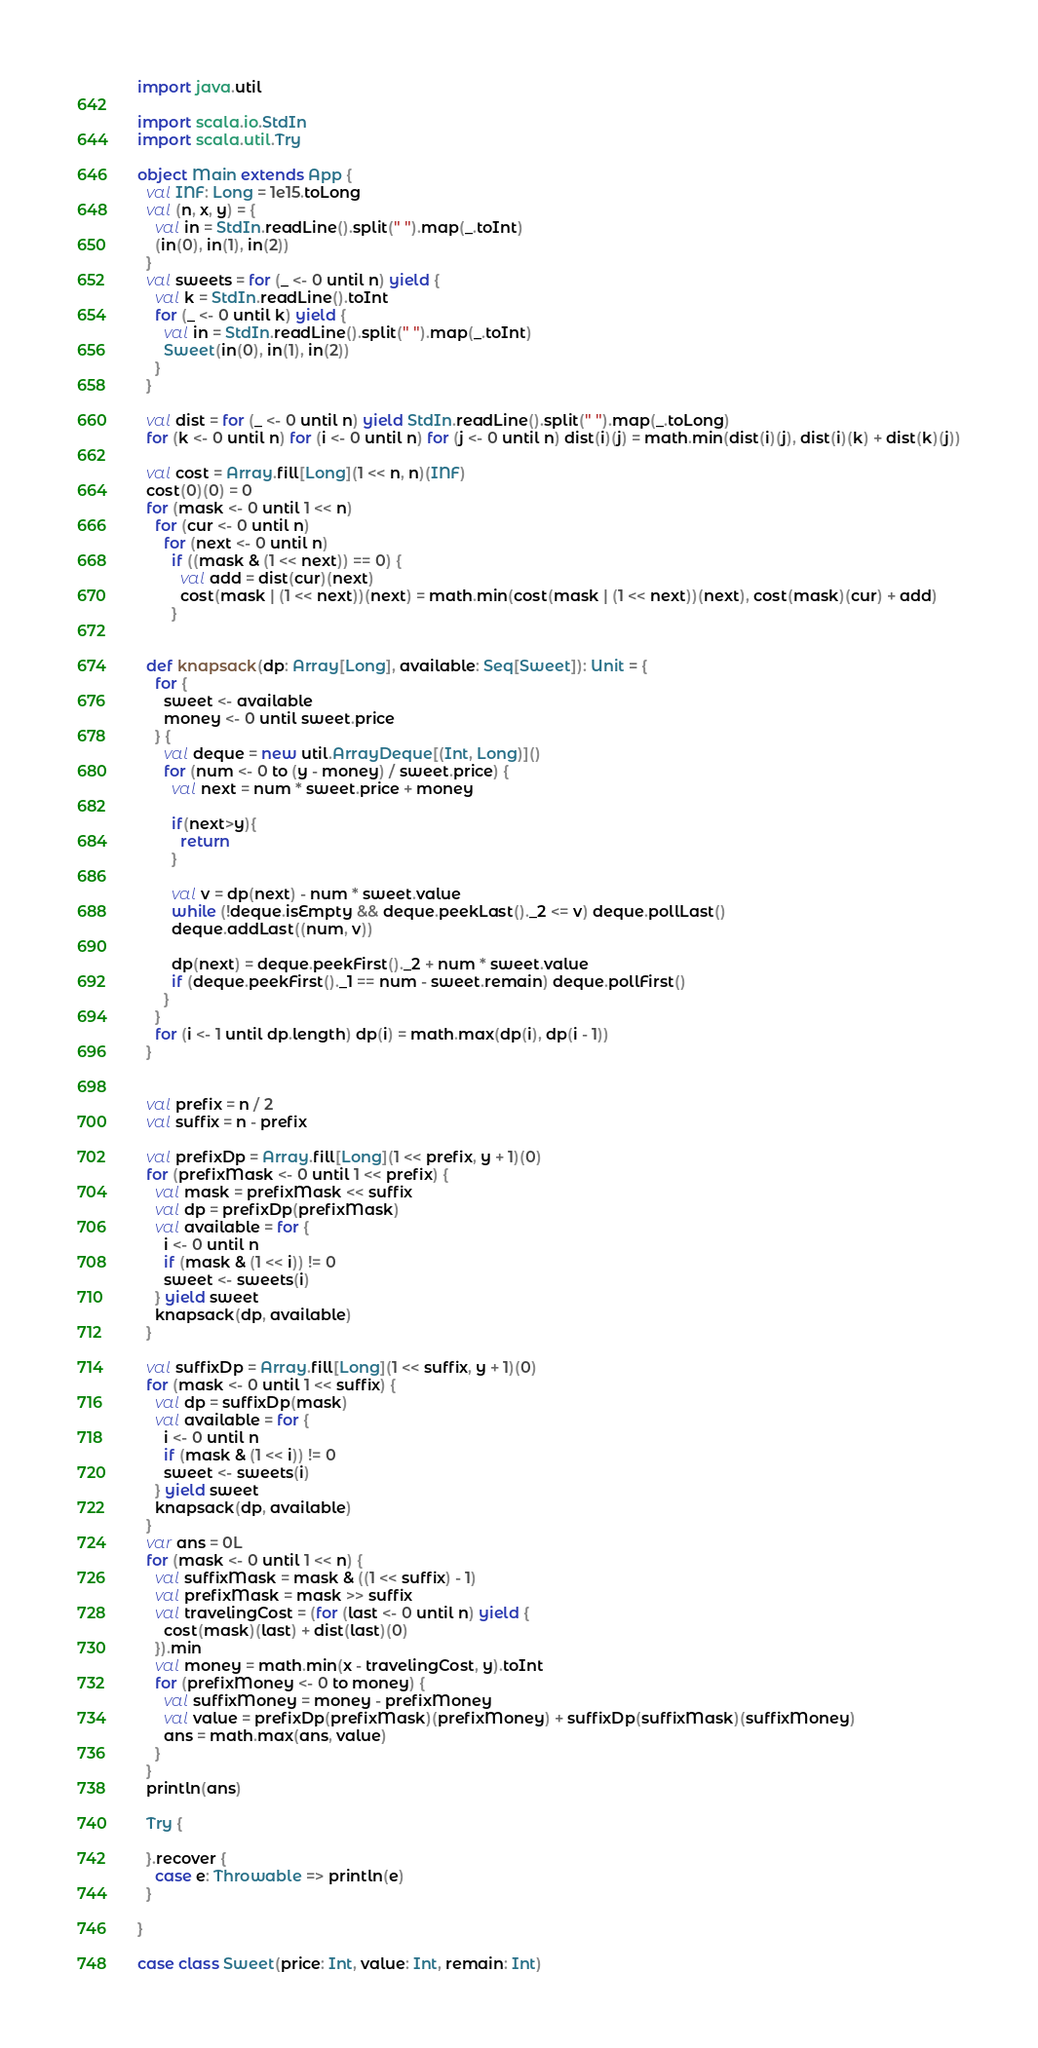Convert code to text. <code><loc_0><loc_0><loc_500><loc_500><_Scala_>import java.util

import scala.io.StdIn
import scala.util.Try

object Main extends App {
  val INF: Long = 1e15.toLong
  val (n, x, y) = {
    val in = StdIn.readLine().split(" ").map(_.toInt)
    (in(0), in(1), in(2))
  }
  val sweets = for (_ <- 0 until n) yield {
    val k = StdIn.readLine().toInt
    for (_ <- 0 until k) yield {
      val in = StdIn.readLine().split(" ").map(_.toInt)
      Sweet(in(0), in(1), in(2))
    }
  }

  val dist = for (_ <- 0 until n) yield StdIn.readLine().split(" ").map(_.toLong)
  for (k <- 0 until n) for (i <- 0 until n) for (j <- 0 until n) dist(i)(j) = math.min(dist(i)(j), dist(i)(k) + dist(k)(j))

  val cost = Array.fill[Long](1 << n, n)(INF)
  cost(0)(0) = 0
  for (mask <- 0 until 1 << n)
    for (cur <- 0 until n)
      for (next <- 0 until n)
        if ((mask & (1 << next)) == 0) {
          val add = dist(cur)(next)
          cost(mask | (1 << next))(next) = math.min(cost(mask | (1 << next))(next), cost(mask)(cur) + add)
        }


  def knapsack(dp: Array[Long], available: Seq[Sweet]): Unit = {
    for {
      sweet <- available
      money <- 0 until sweet.price
    } {
      val deque = new util.ArrayDeque[(Int, Long)]()
      for (num <- 0 to (y - money) / sweet.price) {
        val next = num * sweet.price + money

        if(next>y){
          return 
        }

        val v = dp(next) - num * sweet.value
        while (!deque.isEmpty && deque.peekLast()._2 <= v) deque.pollLast()
        deque.addLast((num, v))

        dp(next) = deque.peekFirst()._2 + num * sweet.value
        if (deque.peekFirst()._1 == num - sweet.remain) deque.pollFirst()
      }
    }
    for (i <- 1 until dp.length) dp(i) = math.max(dp(i), dp(i - 1))
  }


  val prefix = n / 2
  val suffix = n - prefix

  val prefixDp = Array.fill[Long](1 << prefix, y + 1)(0)
  for (prefixMask <- 0 until 1 << prefix) {
    val mask = prefixMask << suffix
    val dp = prefixDp(prefixMask)
    val available = for {
      i <- 0 until n
      if (mask & (1 << i)) != 0
      sweet <- sweets(i)
    } yield sweet
    knapsack(dp, available)
  }

  val suffixDp = Array.fill[Long](1 << suffix, y + 1)(0)
  for (mask <- 0 until 1 << suffix) {
    val dp = suffixDp(mask)
    val available = for {
      i <- 0 until n
      if (mask & (1 << i)) != 0
      sweet <- sweets(i)
    } yield sweet
    knapsack(dp, available)
  }
  var ans = 0L
  for (mask <- 0 until 1 << n) {
    val suffixMask = mask & ((1 << suffix) - 1)
    val prefixMask = mask >> suffix
    val travelingCost = (for (last <- 0 until n) yield {
      cost(mask)(last) + dist(last)(0)
    }).min
    val money = math.min(x - travelingCost, y).toInt
    for (prefixMoney <- 0 to money) {
      val suffixMoney = money - prefixMoney
      val value = prefixDp(prefixMask)(prefixMoney) + suffixDp(suffixMask)(suffixMoney)
      ans = math.max(ans, value)
    }
  }
  println(ans)

  Try {

  }.recover {
    case e: Throwable => println(e)
  }

}

case class Sweet(price: Int, value: Int, remain: Int)</code> 